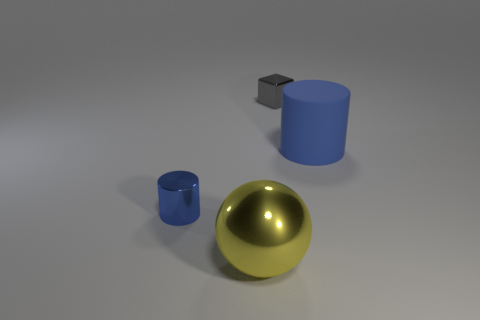The small metal object behind the cylinder on the left side of the large rubber thing is what shape? The small metal object situated behind the larger cylinder on the left side appears to be a cube. It has a distinct geometric form with six equal square faces, leading to its classification as a cube. 